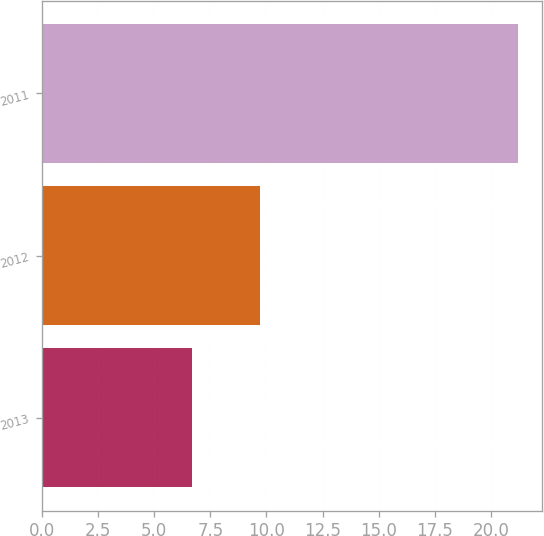<chart> <loc_0><loc_0><loc_500><loc_500><bar_chart><fcel>2013<fcel>2012<fcel>2011<nl><fcel>6.7<fcel>9.7<fcel>21.2<nl></chart> 